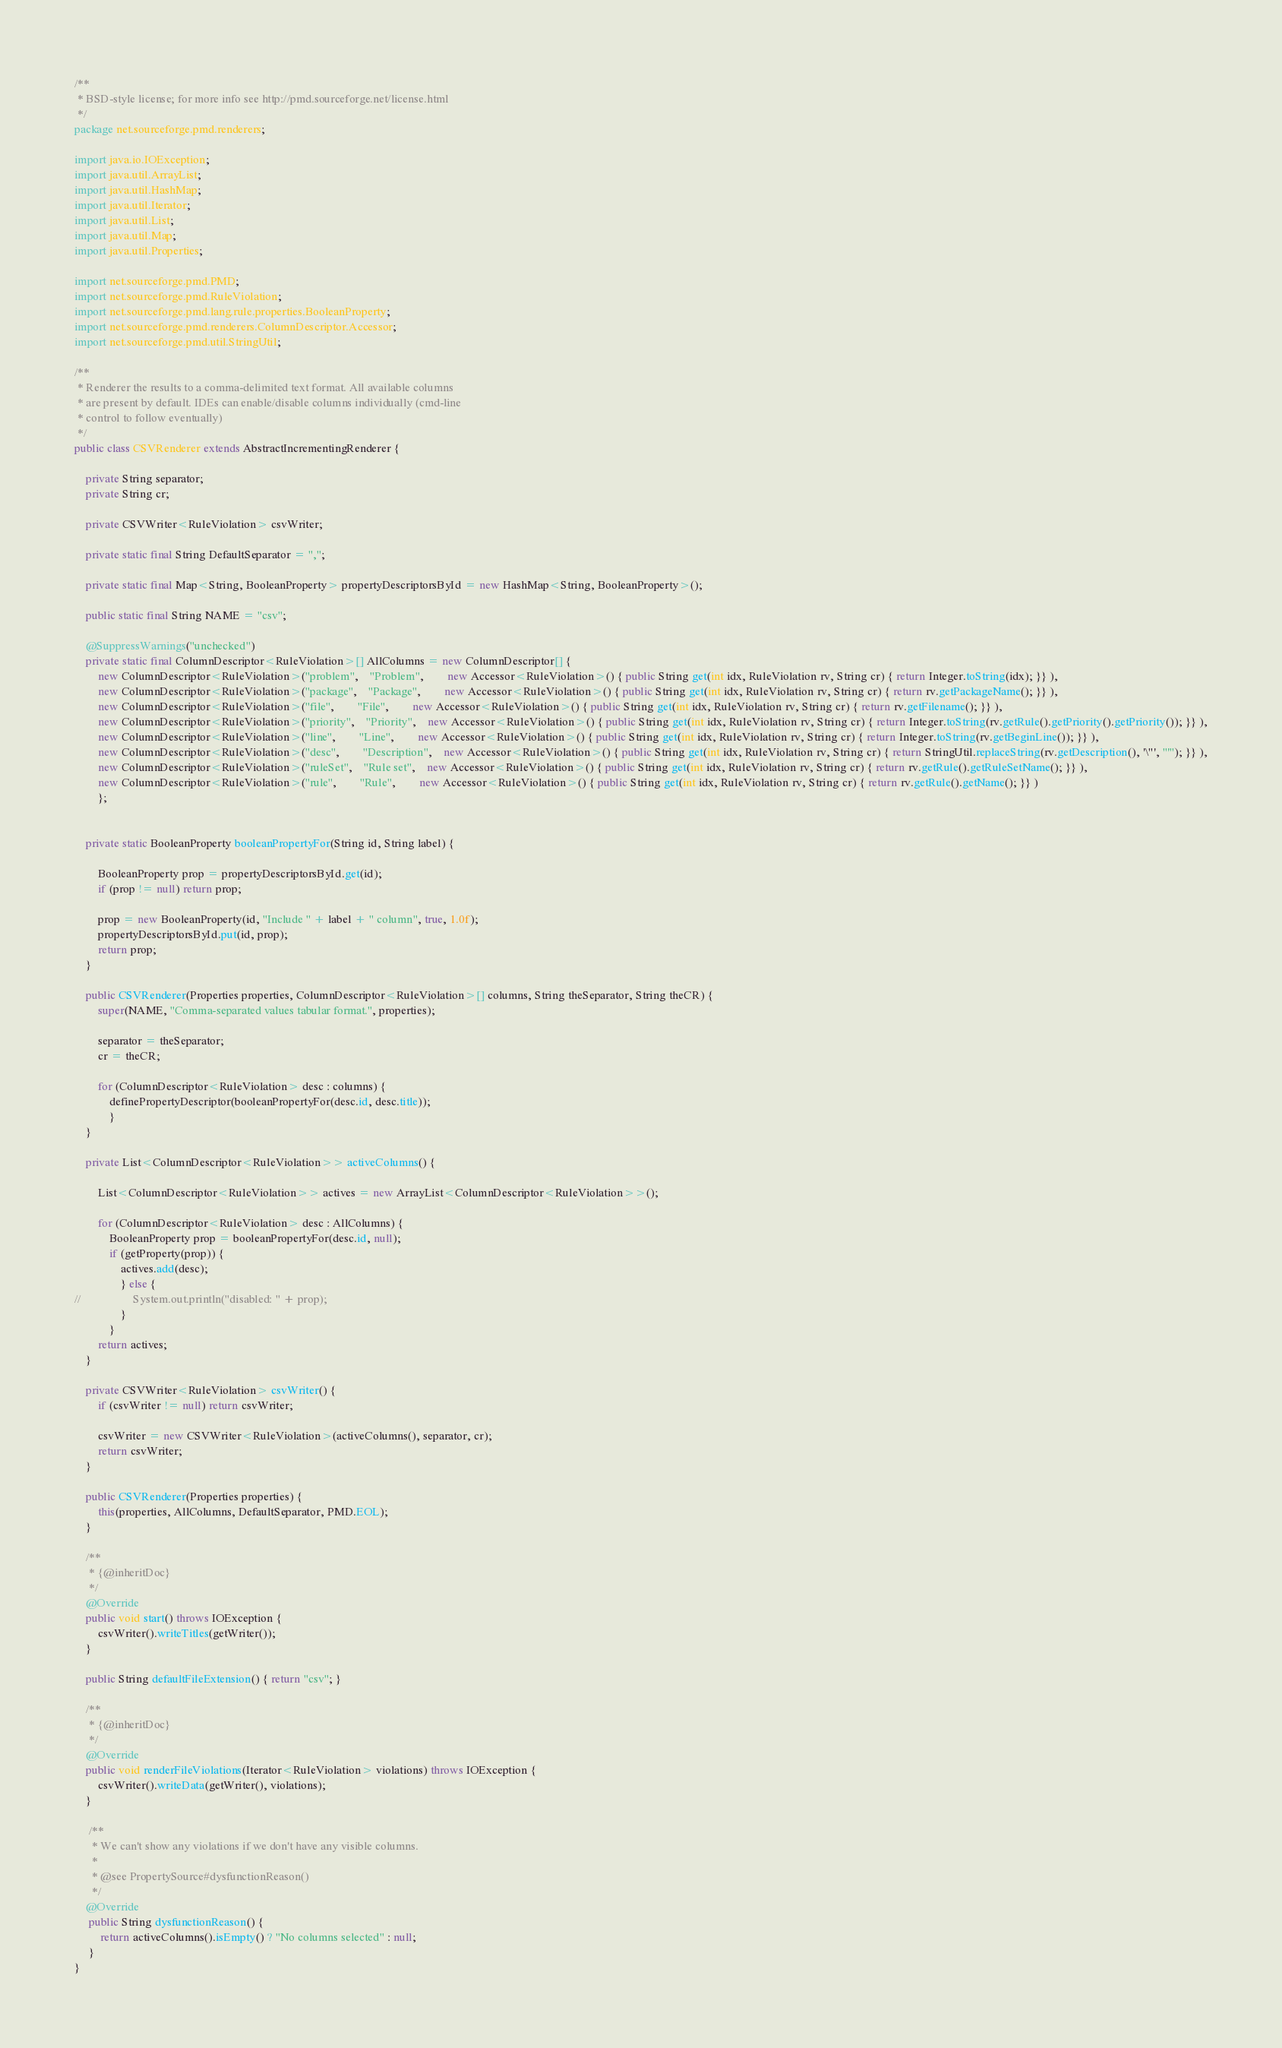Convert code to text. <code><loc_0><loc_0><loc_500><loc_500><_Java_>/**
 * BSD-style license; for more info see http://pmd.sourceforge.net/license.html
 */
package net.sourceforge.pmd.renderers;

import java.io.IOException;
import java.util.ArrayList;
import java.util.HashMap;
import java.util.Iterator;
import java.util.List;
import java.util.Map;
import java.util.Properties;

import net.sourceforge.pmd.PMD;
import net.sourceforge.pmd.RuleViolation;
import net.sourceforge.pmd.lang.rule.properties.BooleanProperty;
import net.sourceforge.pmd.renderers.ColumnDescriptor.Accessor;
import net.sourceforge.pmd.util.StringUtil;

/**
 * Renderer the results to a comma-delimited text format. All available columns
 * are present by default. IDEs can enable/disable columns individually (cmd-line
 * control to follow eventually)
 */
public class CSVRenderer extends AbstractIncrementingRenderer {

    private String separator;
    private String cr;

    private CSVWriter<RuleViolation> csvWriter;

    private static final String DefaultSeparator = ",";

    private static final Map<String, BooleanProperty> propertyDescriptorsById = new HashMap<String, BooleanProperty>();

    public static final String NAME = "csv";

    @SuppressWarnings("unchecked")
	private static final ColumnDescriptor<RuleViolation>[] AllColumns = new ColumnDescriptor[] {
    	new ColumnDescriptor<RuleViolation>("problem", 	"Problem", 		new Accessor<RuleViolation>() { public String get(int idx, RuleViolation rv, String cr) { return Integer.toString(idx); }} ),
    	new ColumnDescriptor<RuleViolation>("package",	"Package", 		new Accessor<RuleViolation>() { public String get(int idx, RuleViolation rv, String cr) { return rv.getPackageName(); }} ),
    	new ColumnDescriptor<RuleViolation>("file",		"File", 		new Accessor<RuleViolation>() { public String get(int idx, RuleViolation rv, String cr) { return rv.getFilename(); }} ),
    	new ColumnDescriptor<RuleViolation>("priority",	"Priority", 	new Accessor<RuleViolation>() { public String get(int idx, RuleViolation rv, String cr) { return Integer.toString(rv.getRule().getPriority().getPriority()); }} ),
    	new ColumnDescriptor<RuleViolation>("line",		"Line", 		new Accessor<RuleViolation>() { public String get(int idx, RuleViolation rv, String cr) { return Integer.toString(rv.getBeginLine()); }} ),
    	new ColumnDescriptor<RuleViolation>("desc",		"Description", 	new Accessor<RuleViolation>() { public String get(int idx, RuleViolation rv, String cr) { return StringUtil.replaceString(rv.getDescription(), '\"', "'"); }} ),
    	new ColumnDescriptor<RuleViolation>("ruleSet",	"Rule set", 	new Accessor<RuleViolation>() { public String get(int idx, RuleViolation rv, String cr) { return rv.getRule().getRuleSetName(); }} ),
    	new ColumnDescriptor<RuleViolation>("rule",		"Rule", 		new Accessor<RuleViolation>() { public String get(int idx, RuleViolation rv, String cr) { return rv.getRule().getName(); }} )
    	};


    private static BooleanProperty booleanPropertyFor(String id, String label) {

    	BooleanProperty prop = propertyDescriptorsById.get(id);
    	if (prop != null) return prop;

    	prop = new BooleanProperty(id, "Include " + label + " column", true, 1.0f);
    	propertyDescriptorsById.put(id, prop);
    	return prop;
    }

    public CSVRenderer(Properties properties, ColumnDescriptor<RuleViolation>[] columns, String theSeparator, String theCR) {
    	super(NAME, "Comma-separated values tabular format.", properties);

    	separator = theSeparator;
    	cr = theCR;

    	for (ColumnDescriptor<RuleViolation> desc : columns) {
    		definePropertyDescriptor(booleanPropertyFor(desc.id, desc.title));
    		}
    }

    private List<ColumnDescriptor<RuleViolation>> activeColumns() {

    	List<ColumnDescriptor<RuleViolation>> actives = new ArrayList<ColumnDescriptor<RuleViolation>>();

     	for (ColumnDescriptor<RuleViolation> desc : AllColumns) {
    		BooleanProperty prop = booleanPropertyFor(desc.id, null);
    		if (getProperty(prop)) {
    			actives.add(desc);
    			} else {
//    				System.out.println("disabled: " + prop);
    			}
    		}
     	return actives;
    }

    private CSVWriter<RuleViolation> csvWriter() {
    	if (csvWriter != null) return csvWriter;

    	csvWriter = new CSVWriter<RuleViolation>(activeColumns(), separator, cr);
    	return csvWriter;
    }

    public CSVRenderer(Properties properties) {
    	this(properties, AllColumns, DefaultSeparator, PMD.EOL);
    }

    /**
     * {@inheritDoc}
     */
    @Override
    public void start() throws IOException {
    	csvWriter().writeTitles(getWriter());
    }

    public String defaultFileExtension() { return "csv"; }

    /**
     * {@inheritDoc}
     */
    @Override
    public void renderFileViolations(Iterator<RuleViolation> violations) throws IOException {
    	csvWriter().writeData(getWriter(), violations);
    }

	 /**
	  * We can't show any violations if we don't have any visible columns.
	  *
	  * @see PropertySource#dysfunctionReason()
	  */
    @Override
	 public String dysfunctionReason() {
		 return activeColumns().isEmpty() ? "No columns selected" : null;
	 }
}
</code> 